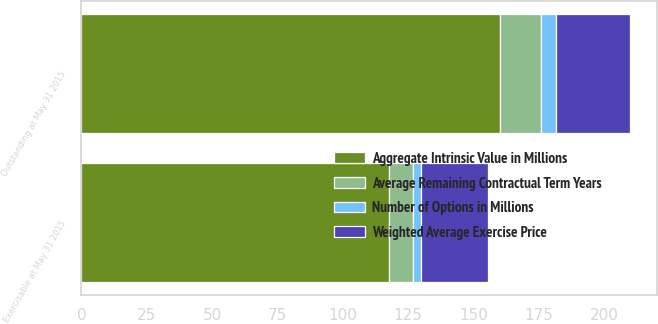Convert chart. <chart><loc_0><loc_0><loc_500><loc_500><stacked_bar_chart><ecel><fcel>Outstanding at May 31 2015<fcel>Exercisable at May 31 2015<nl><fcel>Average Remaining Contractual Term Years<fcel>15.5<fcel>8.9<nl><fcel>Weighted Average Exercise Price<fcel>28.28<fcel>25.29<nl><fcel>Number of Options in Millions<fcel>5.65<fcel>3.37<nl><fcel>Aggregate Intrinsic Value in Millions<fcel>160.4<fcel>117.9<nl></chart> 